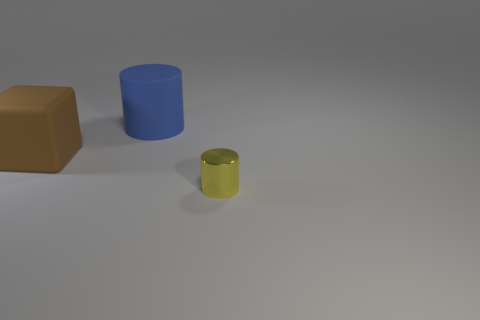Do the large blue thing and the large thing that is on the left side of the large blue cylinder have the same shape?
Offer a very short reply. No. Is there anything else that is the same shape as the brown rubber thing?
Your response must be concise. No. Is the material of the large cylinder the same as the big object that is in front of the big rubber cylinder?
Ensure brevity in your answer.  Yes. There is a matte object to the right of the big matte thing on the left side of the cylinder that is to the left of the tiny yellow metallic thing; what color is it?
Make the answer very short. Blue. Is there anything else that is the same size as the yellow object?
Provide a succinct answer. No. What is the color of the tiny metallic object?
Keep it short and to the point. Yellow. There is a matte thing that is behind the matte object to the left of the cylinder that is behind the metal cylinder; what is its shape?
Provide a short and direct response. Cylinder. What number of other objects are the same color as the tiny shiny cylinder?
Give a very brief answer. 0. Is the number of big matte cylinders that are on the left side of the big rubber block greater than the number of cubes in front of the large blue cylinder?
Your response must be concise. No. There is a tiny shiny thing; are there any large blue cylinders to the left of it?
Provide a short and direct response. Yes. 